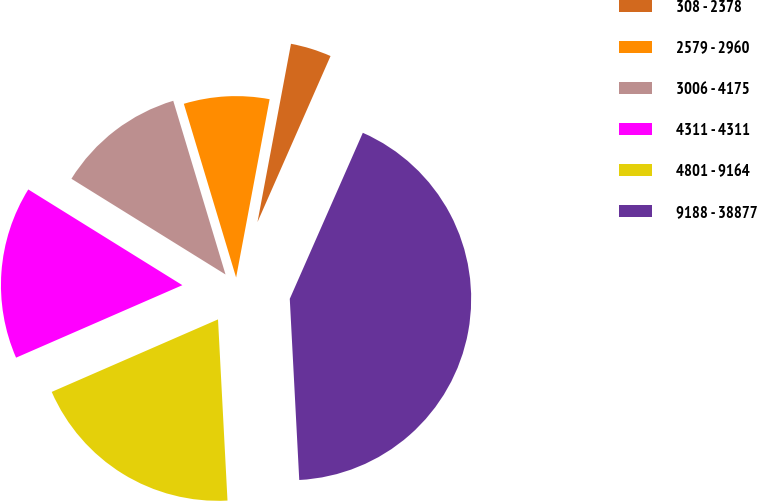Convert chart to OTSL. <chart><loc_0><loc_0><loc_500><loc_500><pie_chart><fcel>308 - 2378<fcel>2579 - 2960<fcel>3006 - 4175<fcel>4311 - 4311<fcel>4801 - 9164<fcel>9188 - 38877<nl><fcel>3.64%<fcel>7.61%<fcel>11.5%<fcel>15.39%<fcel>19.29%<fcel>42.57%<nl></chart> 